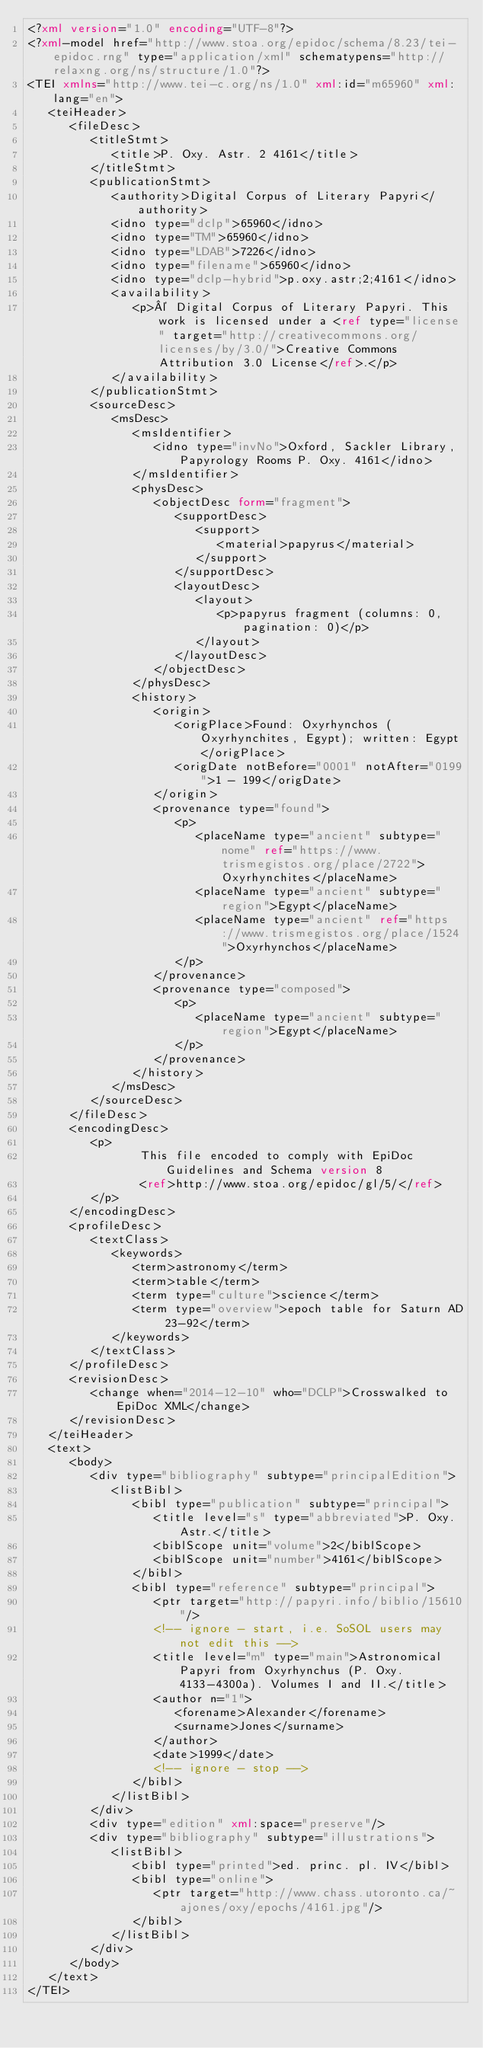<code> <loc_0><loc_0><loc_500><loc_500><_XML_><?xml version="1.0" encoding="UTF-8"?>
<?xml-model href="http://www.stoa.org/epidoc/schema/8.23/tei-epidoc.rng" type="application/xml" schematypens="http://relaxng.org/ns/structure/1.0"?>
<TEI xmlns="http://www.tei-c.org/ns/1.0" xml:id="m65960" xml:lang="en">
   <teiHeader>
      <fileDesc>
         <titleStmt>
            <title>P. Oxy. Astr. 2 4161</title>
         </titleStmt>
         <publicationStmt>
            <authority>Digital Corpus of Literary Papyri</authority>
            <idno type="dclp">65960</idno>
            <idno type="TM">65960</idno>
            <idno type="LDAB">7226</idno>
            <idno type="filename">65960</idno>
            <idno type="dclp-hybrid">p.oxy.astr;2;4161</idno>
            <availability>
               <p>© Digital Corpus of Literary Papyri. This work is licensed under a <ref type="license" target="http://creativecommons.org/licenses/by/3.0/">Creative Commons Attribution 3.0 License</ref>.</p>
            </availability>
         </publicationStmt>
         <sourceDesc>
            <msDesc>
               <msIdentifier>
                  <idno type="invNo">Oxford, Sackler Library, Papyrology Rooms P. Oxy. 4161</idno>
               </msIdentifier>
               <physDesc>
                  <objectDesc form="fragment">
                     <supportDesc>
                        <support>
                           <material>papyrus</material>
                        </support>
                     </supportDesc>
                     <layoutDesc>
                        <layout>
                           <p>papyrus fragment (columns: 0, pagination: 0)</p>
                        </layout>
                     </layoutDesc>
                  </objectDesc>
               </physDesc>
               <history>
                  <origin>
                     <origPlace>Found: Oxyrhynchos (Oxyrhynchites, Egypt); written: Egypt</origPlace>
                     <origDate notBefore="0001" notAfter="0199">1 - 199</origDate>
                  </origin>
                  <provenance type="found">
                     <p>
                        <placeName type="ancient" subtype="nome" ref="https://www.trismegistos.org/place/2722">Oxyrhynchites</placeName>
                        <placeName type="ancient" subtype="region">Egypt</placeName>
                        <placeName type="ancient" ref="https://www.trismegistos.org/place/1524">Oxyrhynchos</placeName>
                     </p>
                  </provenance>
                  <provenance type="composed">
                     <p>
                        <placeName type="ancient" subtype="region">Egypt</placeName>
                     </p>
                  </provenance>
               </history>
            </msDesc>
         </sourceDesc>
      </fileDesc>
      <encodingDesc>
         <p>
                This file encoded to comply with EpiDoc Guidelines and Schema version 8
                <ref>http://www.stoa.org/epidoc/gl/5/</ref>
         </p>
      </encodingDesc>
      <profileDesc>
         <textClass>
            <keywords>
               <term>astronomy</term>
               <term>table</term>
               <term type="culture">science</term>
               <term type="overview">epoch table for Saturn AD 23-92</term>
            </keywords>
         </textClass>
      </profileDesc>
      <revisionDesc>
         <change when="2014-12-10" who="DCLP">Crosswalked to EpiDoc XML</change>
      </revisionDesc>
   </teiHeader>
   <text>
      <body>
         <div type="bibliography" subtype="principalEdition">
            <listBibl>
               <bibl type="publication" subtype="principal">
                  <title level="s" type="abbreviated">P. Oxy. Astr.</title>
                  <biblScope unit="volume">2</biblScope>
                  <biblScope unit="number">4161</biblScope>
               </bibl>
               <bibl type="reference" subtype="principal">
                  <ptr target="http://papyri.info/biblio/15610"/>
                  <!-- ignore - start, i.e. SoSOL users may not edit this -->
                  <title level="m" type="main">Astronomical Papyri from Oxyrhynchus (P. Oxy. 4133-4300a). Volumes I and II.</title>
                  <author n="1">
                     <forename>Alexander</forename>
                     <surname>Jones</surname>
                  </author>
                  <date>1999</date>
                  <!-- ignore - stop -->
               </bibl>
            </listBibl>
         </div>
         <div type="edition" xml:space="preserve"/>
         <div type="bibliography" subtype="illustrations">
            <listBibl>
               <bibl type="printed">ed. princ. pl. IV</bibl>
               <bibl type="online">
                  <ptr target="http://www.chass.utoronto.ca/~ajones/oxy/epochs/4161.jpg"/>
               </bibl>
            </listBibl>
         </div>
      </body>
   </text>
</TEI>
</code> 